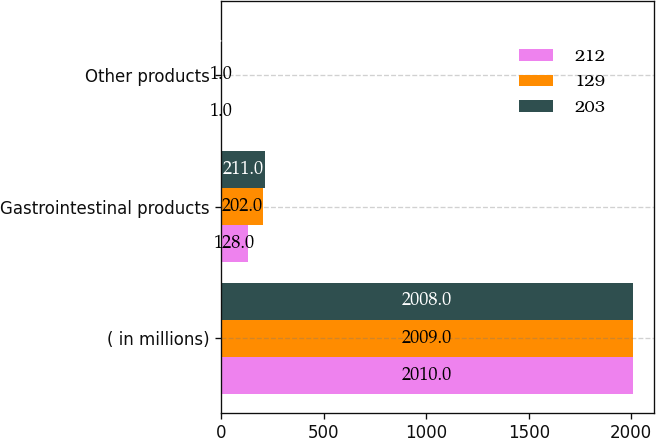Convert chart. <chart><loc_0><loc_0><loc_500><loc_500><stacked_bar_chart><ecel><fcel>( in millions)<fcel>Gastrointestinal products<fcel>Other products<nl><fcel>212<fcel>2010<fcel>128<fcel>1<nl><fcel>129<fcel>2009<fcel>202<fcel>1<nl><fcel>203<fcel>2008<fcel>211<fcel>1<nl></chart> 